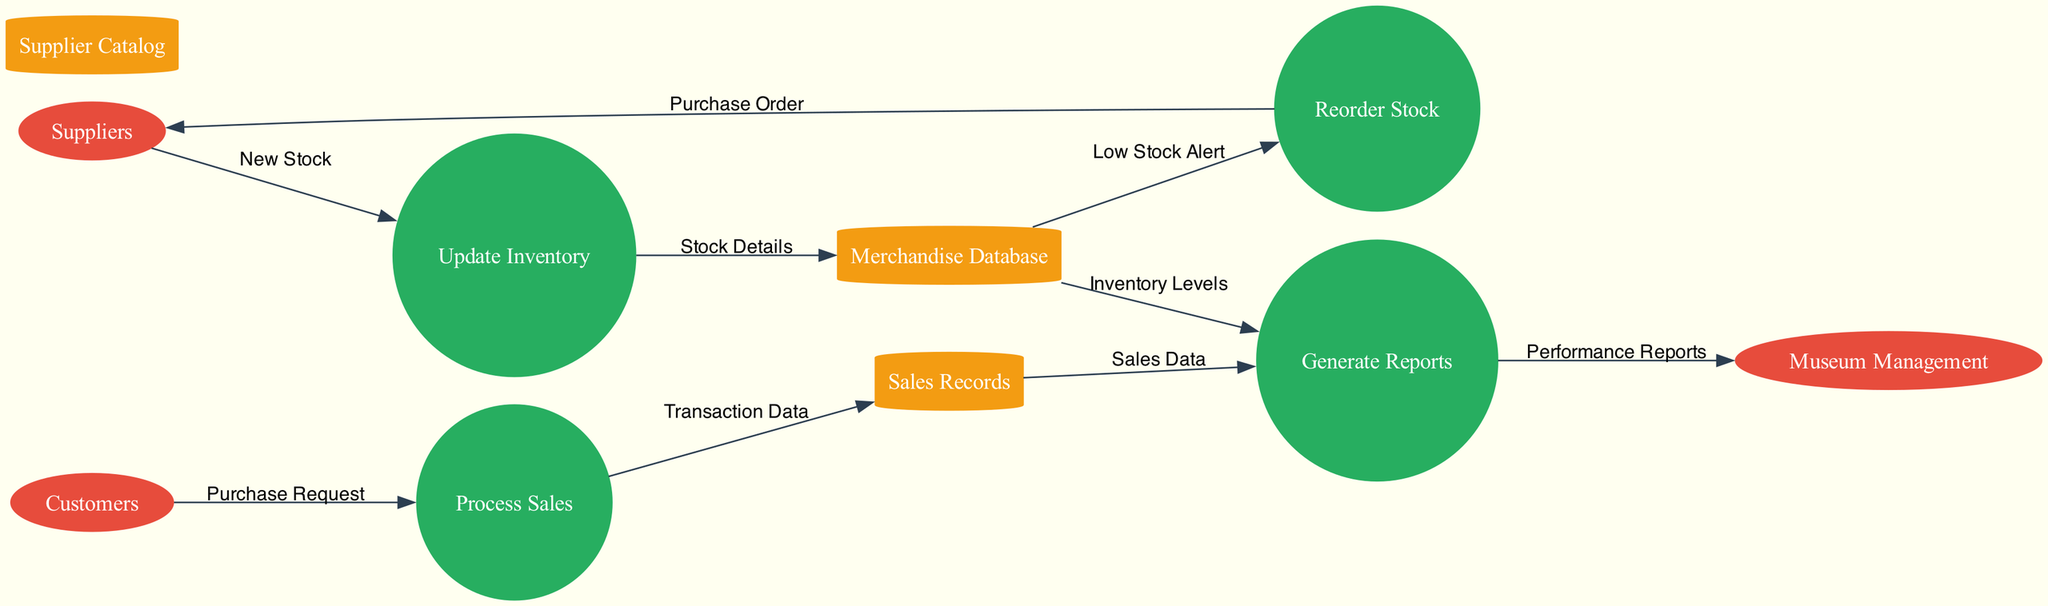What are the external entities represented in the diagram? The diagram lists three external entities: Suppliers, Customers, and Museum Management. These are marked as ellipses, indicating they are outside the system being analyzed.
Answer: Suppliers, Customers, Museum Management How many processes are there in the diagram? Upon reviewing the diagram, there are four distinct processes: Update Inventory, Process Sales, Generate Reports, and Reorder Stock. Each process is represented by a circle, which allows for easy identification.
Answer: 4 What data is sent from Suppliers to the Update Inventory process? In the diagram, the data flow from Suppliers to Update Inventory is labeled as "New Stock." This indicates the type of data that Suppliers provide to inform the inventory update.
Answer: New Stock Which process generates performance reports for Museum Management? The diagram shows that the Generate Reports process sends information to Museum Management, labeled as "Performance Reports." This indicates that this process is responsible for creating the performance reports that are sent to management.
Answer: Generate Reports What triggers the Reorder Stock process? According to the diagram, the Reorder Stock process is triggered by a "Low Stock Alert" data flow from the Merchandise Database. This shows the relationship and condition that prompts reordering.
Answer: Low Stock Alert How does the Process Sales interact with Sales Records? The Process Sales sends "Transaction Data" to the Sales Records data store, depicting how successful sales transactions are stored for future analysis. This illustrates a key part of the sales management process.
Answer: Transaction Data Which data store is involved in generating reports? There are two data stores involved in the Generate Reports process: Merchandise Database and Sales Records. The diagram shows flows from both of these data stores to the Generate Reports process, indicating their role in supplying necessary data.
Answer: Merchandise Database, Sales Records What type of diagram is this? This is a Data Flow Diagram, which is specifically used to visualize the flow of data within a system. The components arranged visually clarify how different external entities, processes, and data stores interact.
Answer: Data Flow Diagram How many data stores are present in the diagram? The diagram contains three data stores: Merchandise Database, Sales Records, and Supplier Catalog. Each of these stores is represented as a cylinder, denoting how they hold and manage data within the system.
Answer: 3 